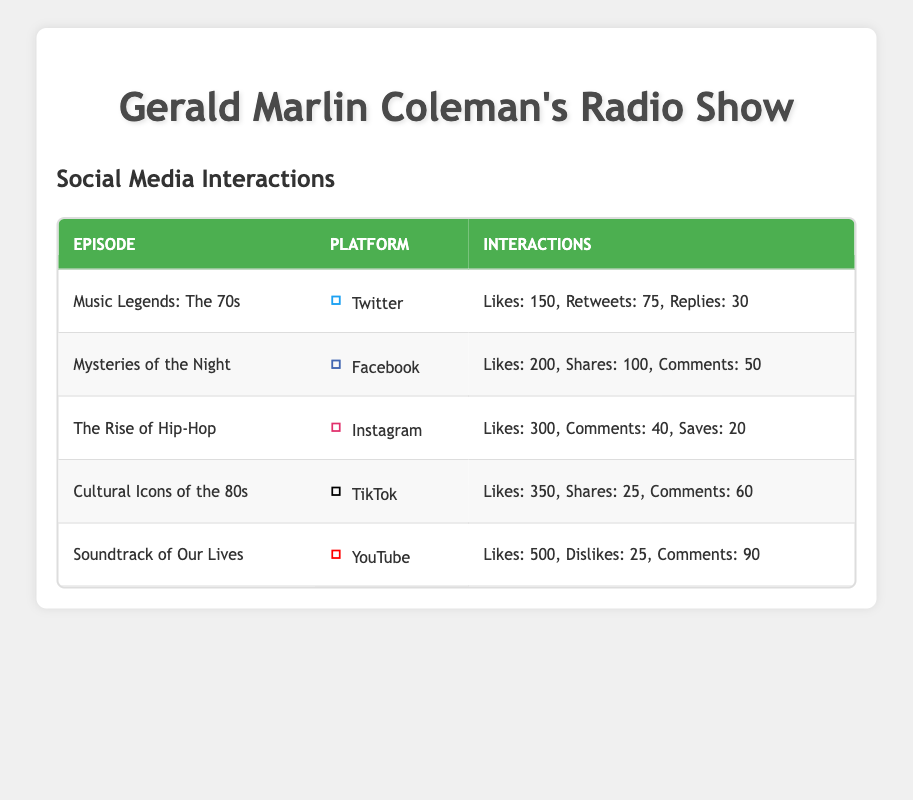What was the total number of Likes across all episodes? The Likes for each episode are: Music Legends: The 70s (150), Mysteries of the Night (200), The Rise of Hip-Hop (300), Cultural Icons of the 80s (350), and Soundtrack of Our Lives (500). Adding these gives: 150 + 200 + 300 + 350 + 500 = 1500.
Answer: 1500 Which platform had the highest number of Comments? The Comments for each platform are: Twitter (30), Facebook (50), Instagram (40), TikTok (60), YouTube (90). The highest number is found in YouTube with 90 Comments.
Answer: YouTube Did any episode on TikTok have more Likes than any episode on YouTube? TikTok’s Likes are 350 (Cultural Icons of the 80s) and YouTube’s Likes are 500 (Soundtrack of Our Lives). Since 350 is less than 500, the answer is no.
Answer: No Which episode had the highest total interactions (sum of all engagement metrics)? The interactions for each episode are summed as follows: Music Legends: The 70s (255), Mysteries of the Night (350), The Rise of Hip-Hop (360), Cultural Icons of the 80s (435), Soundtrack of Our Lives (615). The highest total interacts is from Soundtrack of Our Lives with 615 total interactions.
Answer: Soundtrack of Our Lives On which platform did the episode "The Rise of Hip-Hop" get the most Likes compared to other platforms? The Likes for "The Rise of Hip-Hop" was 300 on Instagram. The other platforms had: Twitter (150), Facebook (200), TikTok (350), and YouTube (500). Since 300 is less than TikTok and YouTube but more than Twitter and Facebook, the answer is Instagram was not the most but was the second highest.
Answer: Instagram 